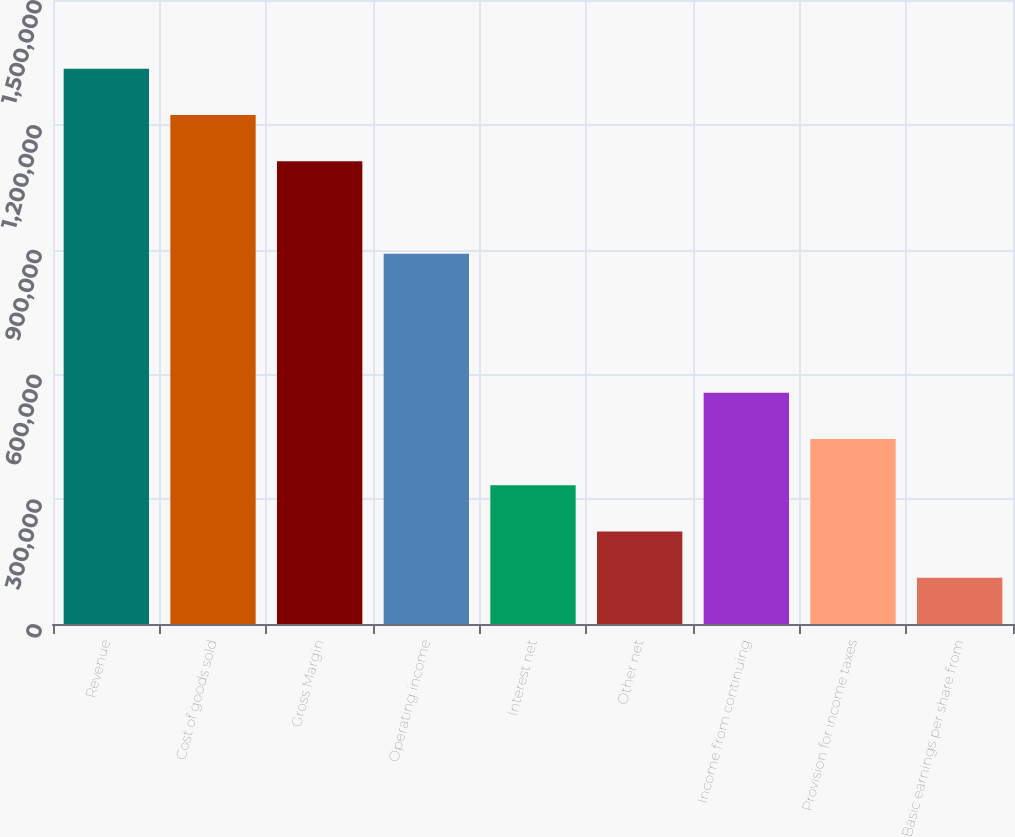Convert chart. <chart><loc_0><loc_0><loc_500><loc_500><bar_chart><fcel>Revenue<fcel>Cost of goods sold<fcel>Gross Margin<fcel>Operating income<fcel>Interest net<fcel>Other net<fcel>Income from continuing<fcel>Provision for income taxes<fcel>Basic earnings per share from<nl><fcel>1.33482e+06<fcel>1.22359e+06<fcel>1.11235e+06<fcel>889881<fcel>333706<fcel>222471<fcel>556176<fcel>444941<fcel>111236<nl></chart> 